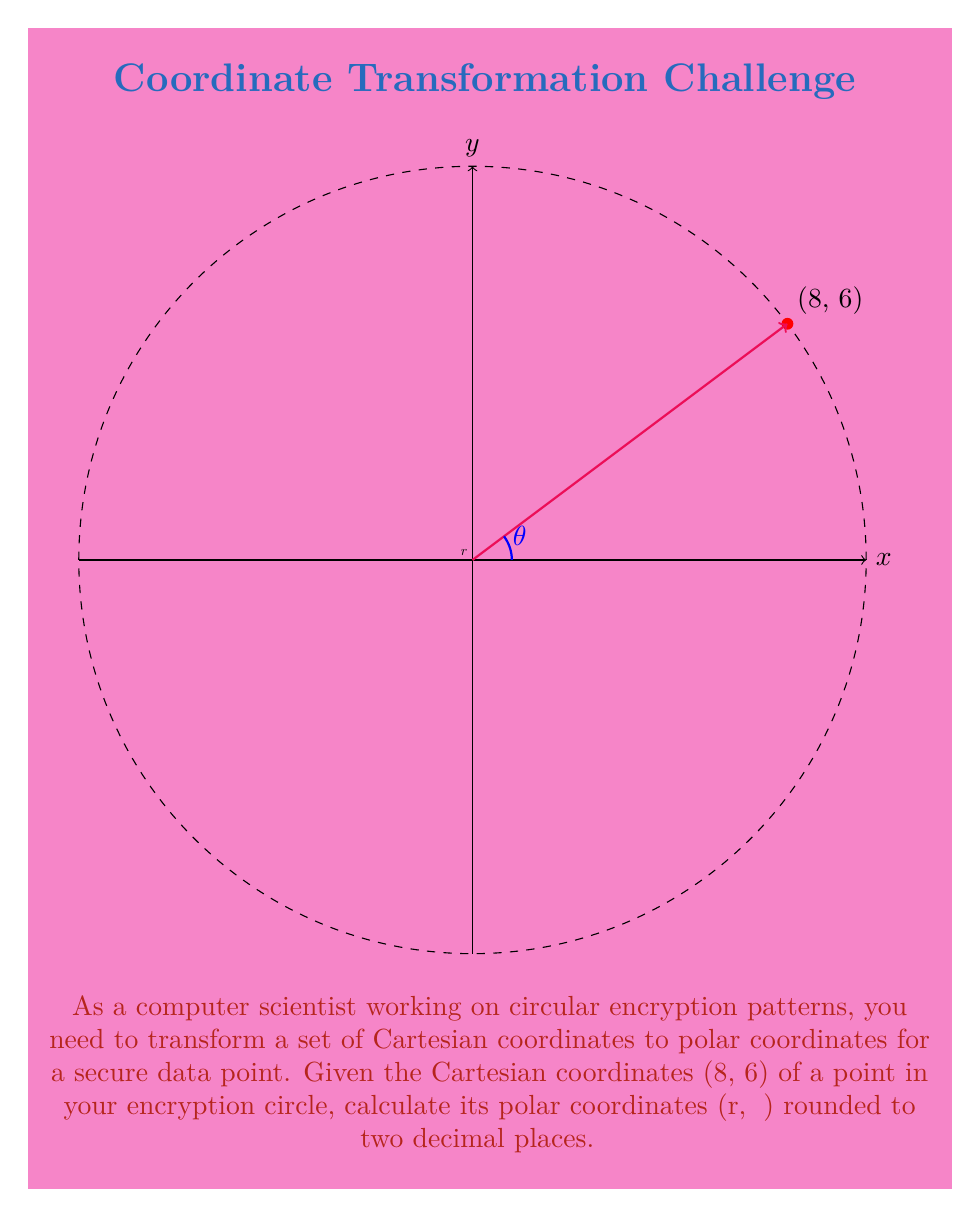Show me your answer to this math problem. To transform Cartesian coordinates (x, y) to polar coordinates (r, θ), we use the following formulas:

1. For the radius r:
   $$r = \sqrt{x^2 + y^2}$$

2. For the angle θ (in radians):
   $$\theta = \tan^{-1}\left(\frac{y}{x}\right)$$

   Note: We need to consider the quadrant to determine the correct angle.

Step 1: Calculate r
$$r = \sqrt{8^2 + 6^2} = \sqrt{64 + 36} = \sqrt{100} = 10$$

Step 2: Calculate θ
$$\theta = \tan^{-1}\left(\frac{6}{8}\right) = \tan^{-1}(0.75) \approx 0.6435 \text{ radians}$$

Step 3: Convert θ to degrees
$$0.6435 \text{ radians} \times \frac{180°}{\pi} \approx 36.87°$$

Step 4: Round both values to two decimal places
r ≈ 10.00
θ ≈ 36.87°

Therefore, the polar coordinates are (10.00, 36.87°).
Answer: (10.00, 36.87°) 